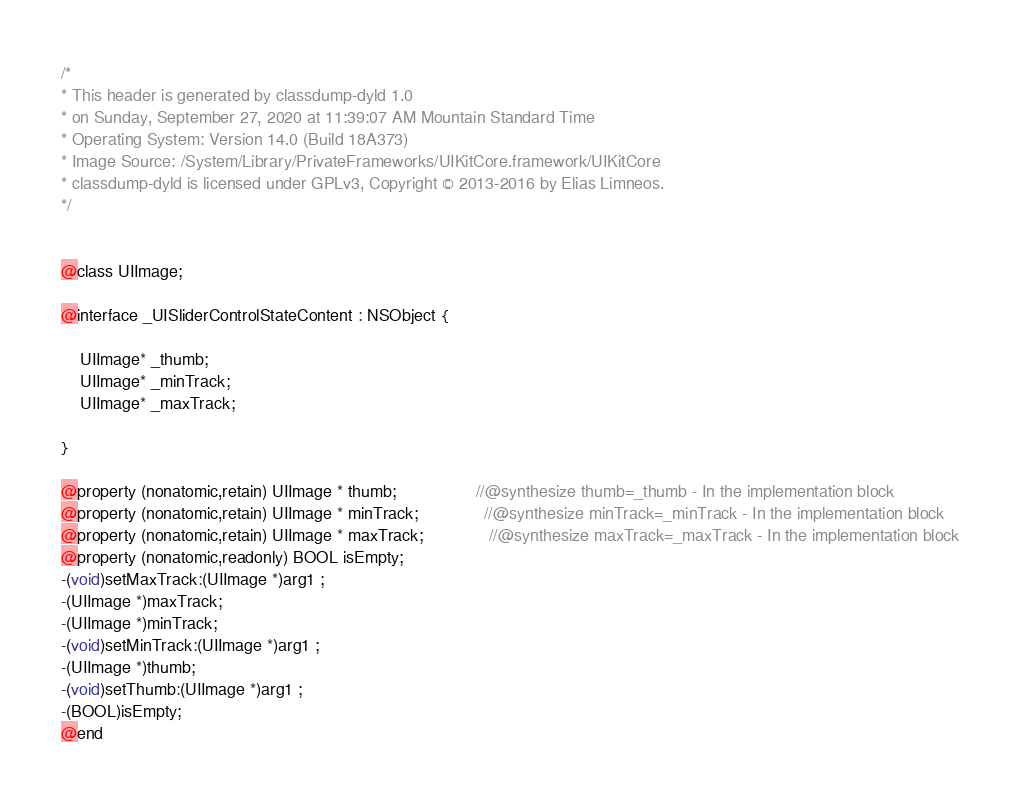<code> <loc_0><loc_0><loc_500><loc_500><_C_>/*
* This header is generated by classdump-dyld 1.0
* on Sunday, September 27, 2020 at 11:39:07 AM Mountain Standard Time
* Operating System: Version 14.0 (Build 18A373)
* Image Source: /System/Library/PrivateFrameworks/UIKitCore.framework/UIKitCore
* classdump-dyld is licensed under GPLv3, Copyright © 2013-2016 by Elias Limneos.
*/


@class UIImage;

@interface _UISliderControlStateContent : NSObject {

	UIImage* _thumb;
	UIImage* _minTrack;
	UIImage* _maxTrack;

}

@property (nonatomic,retain) UIImage * thumb;                 //@synthesize thumb=_thumb - In the implementation block
@property (nonatomic,retain) UIImage * minTrack;              //@synthesize minTrack=_minTrack - In the implementation block
@property (nonatomic,retain) UIImage * maxTrack;              //@synthesize maxTrack=_maxTrack - In the implementation block
@property (nonatomic,readonly) BOOL isEmpty; 
-(void)setMaxTrack:(UIImage *)arg1 ;
-(UIImage *)maxTrack;
-(UIImage *)minTrack;
-(void)setMinTrack:(UIImage *)arg1 ;
-(UIImage *)thumb;
-(void)setThumb:(UIImage *)arg1 ;
-(BOOL)isEmpty;
@end

</code> 